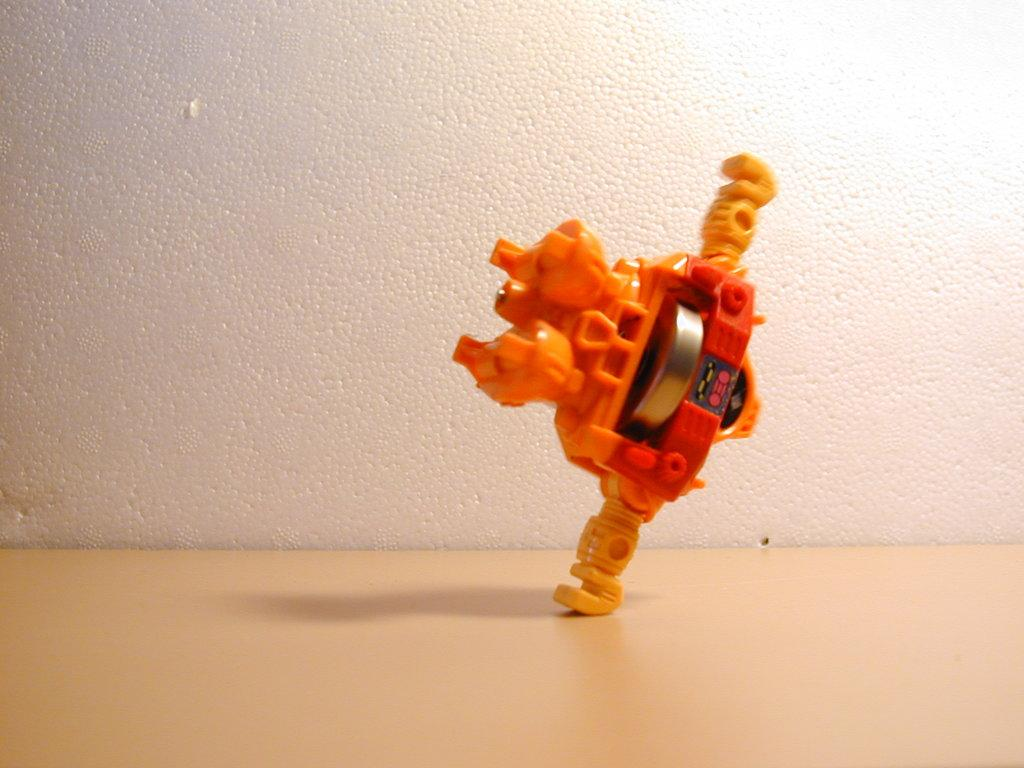What color is the toy in the image? The toy in the image is orange. What is the toy placed on in the image? The toy is on a cream color surface. What can be seen in the background of the image? There is a wall visible in the background of the image. Can you see any ocean waves in the image? There is no ocean or waves present in the image; it features an orange toy on a cream color surface with a wall visible in the background. 